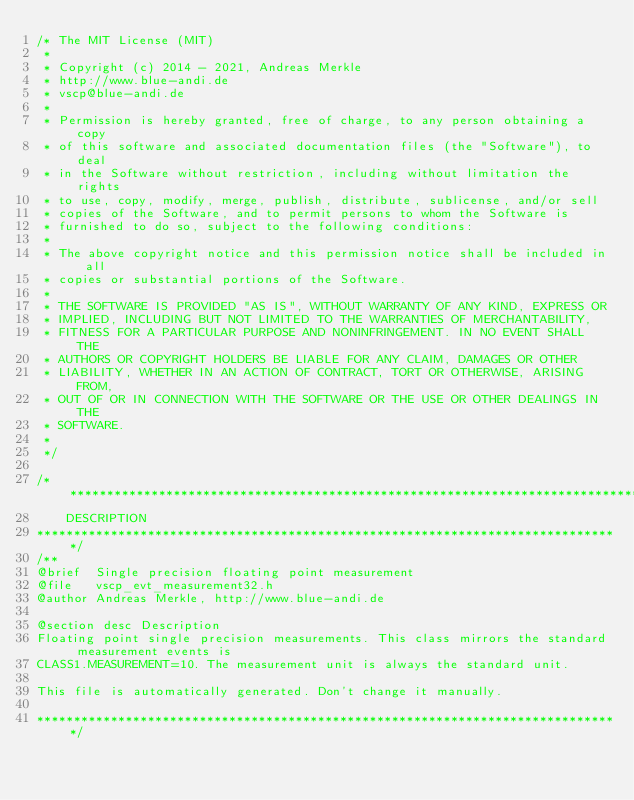Convert code to text. <code><loc_0><loc_0><loc_500><loc_500><_C_>/* The MIT License (MIT)
 *
 * Copyright (c) 2014 - 2021, Andreas Merkle
 * http://www.blue-andi.de
 * vscp@blue-andi.de
 *
 * Permission is hereby granted, free of charge, to any person obtaining a copy
 * of this software and associated documentation files (the "Software"), to deal
 * in the Software without restriction, including without limitation the rights
 * to use, copy, modify, merge, publish, distribute, sublicense, and/or sell
 * copies of the Software, and to permit persons to whom the Software is
 * furnished to do so, subject to the following conditions:
 *
 * The above copyright notice and this permission notice shall be included in all
 * copies or substantial portions of the Software.
 *
 * THE SOFTWARE IS PROVIDED "AS IS", WITHOUT WARRANTY OF ANY KIND, EXPRESS OR
 * IMPLIED, INCLUDING BUT NOT LIMITED TO THE WARRANTIES OF MERCHANTABILITY,
 * FITNESS FOR A PARTICULAR PURPOSE AND NONINFRINGEMENT. IN NO EVENT SHALL THE
 * AUTHORS OR COPYRIGHT HOLDERS BE LIABLE FOR ANY CLAIM, DAMAGES OR OTHER
 * LIABILITY, WHETHER IN AN ACTION OF CONTRACT, TORT OR OTHERWISE, ARISING FROM,
 * OUT OF OR IN CONNECTION WITH THE SOFTWARE OR THE USE OR OTHER DEALINGS IN THE
 * SOFTWARE.
 *
 */

/*******************************************************************************
    DESCRIPTION
*******************************************************************************/
/**
@brief  Single precision floating point measurement
@file   vscp_evt_measurement32.h
@author Andreas Merkle, http://www.blue-andi.de

@section desc Description
Floating point single precision measurements. This class mirrors the standard measurement events is
CLASS1.MEASUREMENT=10. The measurement unit is always the standard unit.

This file is automatically generated. Don't change it manually.

*******************************************************************************/
</code> 